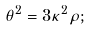Convert formula to latex. <formula><loc_0><loc_0><loc_500><loc_500>\theta ^ { 2 } = 3 \kappa ^ { 2 } \rho ;</formula> 